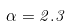Convert formula to latex. <formula><loc_0><loc_0><loc_500><loc_500>\alpha = 2 . 3</formula> 